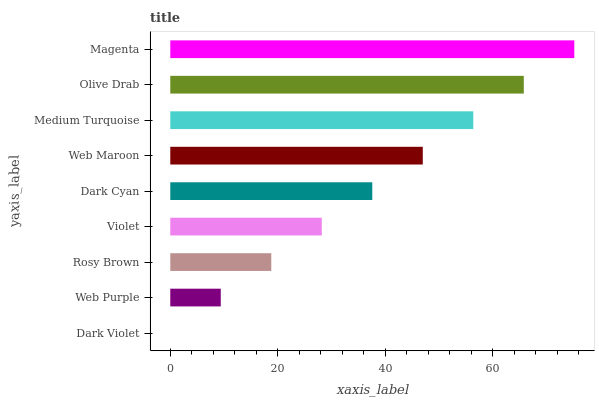Is Dark Violet the minimum?
Answer yes or no. Yes. Is Magenta the maximum?
Answer yes or no. Yes. Is Web Purple the minimum?
Answer yes or no. No. Is Web Purple the maximum?
Answer yes or no. No. Is Web Purple greater than Dark Violet?
Answer yes or no. Yes. Is Dark Violet less than Web Purple?
Answer yes or no. Yes. Is Dark Violet greater than Web Purple?
Answer yes or no. No. Is Web Purple less than Dark Violet?
Answer yes or no. No. Is Dark Cyan the high median?
Answer yes or no. Yes. Is Dark Cyan the low median?
Answer yes or no. Yes. Is Web Maroon the high median?
Answer yes or no. No. Is Dark Violet the low median?
Answer yes or no. No. 